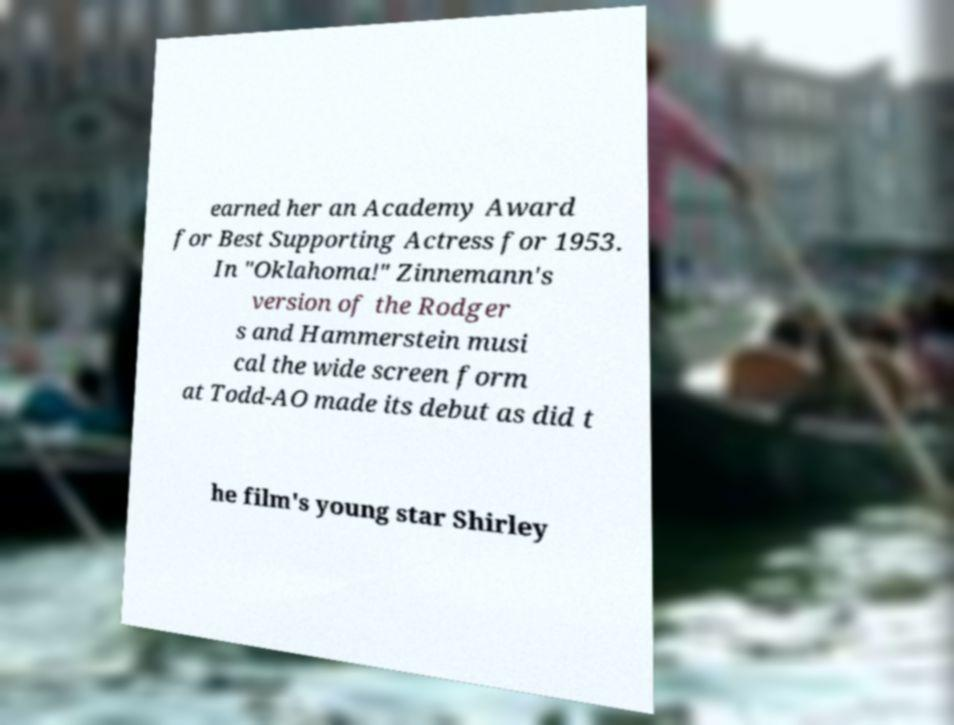For documentation purposes, I need the text within this image transcribed. Could you provide that? earned her an Academy Award for Best Supporting Actress for 1953. In "Oklahoma!" Zinnemann's version of the Rodger s and Hammerstein musi cal the wide screen form at Todd-AO made its debut as did t he film's young star Shirley 